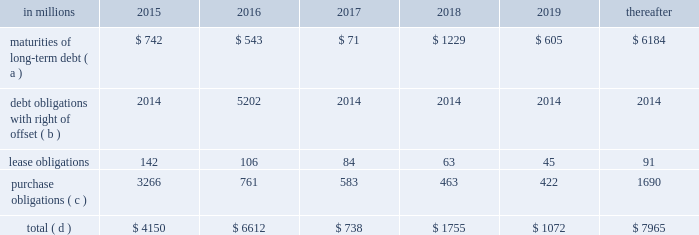On the credit rating of the company and a $ 200 million term loan with an interest rate of libor plus a margin of 175 basis points , both with maturity dates in 2017 .
The proceeds from these borrowings were used , along with available cash , to fund the acquisition of temple- inland .
During 2012 , international paper fully repaid the $ 1.2 billion term loan .
International paper utilizes interest rate swaps to change the mix of fixed and variable rate debt and manage interest expense .
At december 31 , 2012 , international paper had interest rate swaps with a total notional amount of $ 150 million and maturities in 2013 ( see note 14 derivatives and hedging activities on pages 70 through 74 of item 8 .
Financial statements and supplementary data ) .
During 2012 , existing swaps and the amortization of deferred gains on previously terminated swaps decreased the weighted average cost of debt from 6.8% ( 6.8 % ) to an effective rate of 6.6% ( 6.6 % ) .
The inclusion of the offsetting interest income from short- term investments reduced this effective rate to 6.2% ( 6.2 % ) .
Other financing activities during 2012 included the issuance of approximately 1.9 million shares of treasury stock , net of restricted stock withholding , and 1.0 million shares of common stock for various incentive plans , including stock options exercises that generated approximately $ 108 million of cash .
Payment of restricted stock withholding taxes totaled $ 35 million .
Off-balance sheet variable interest entities information concerning off-balance sheet variable interest entities is set forth in note 12 variable interest entities and preferred securities of subsidiaries on pages 67 through 69 of item 8 .
Financial statements and supplementary data for discussion .
Liquidity and capital resources outlook for 2015 capital expenditures and long-term debt international paper expects to be able to meet projected capital expenditures , service existing debt and meet working capital and dividend requirements during 2015 through current cash balances and cash from operations .
Additionally , the company has existing credit facilities totaling $ 2.0 billion of which nothing has been used .
The company was in compliance with all its debt covenants at december 31 , 2014 .
The company 2019s financial covenants require the maintenance of a minimum net worth of $ 9 billion and a total debt-to- capital ratio of less than 60% ( 60 % ) .
Net worth is defined as the sum of common stock , paid-in capital and retained earnings , less treasury stock plus any cumulative goodwill impairment charges .
The calculation also excludes accumulated other comprehensive income/ loss and nonrecourse financial liabilities of special purpose entities .
The total debt-to-capital ratio is defined as total debt divided by the sum of total debt plus net worth .
At december 31 , 2014 , international paper 2019s net worth was $ 14.0 billion , and the total-debt- to-capital ratio was 40% ( 40 % ) .
The company will continue to rely upon debt and capital markets for the majority of any necessary long-term funding not provided by operating cash flows .
Funding decisions will be guided by our capital structure planning objectives .
The primary goals of the company 2019s capital structure planning are to maximize financial flexibility and preserve liquidity while reducing interest expense .
The majority of international paper 2019s debt is accessed through global public capital markets where we have a wide base of investors .
Maintaining an investment grade credit rating is an important element of international paper 2019s financing strategy .
At december 31 , 2014 , the company held long-term credit ratings of bbb ( stable outlook ) and baa2 ( stable outlook ) by s&p and moody 2019s , respectively .
Contractual obligations for future payments under existing debt and lease commitments and purchase obligations at december 31 , 2014 , were as follows: .
( a ) total debt includes scheduled principal payments only .
( b ) represents debt obligations borrowed from non-consolidated variable interest entities for which international paper has , and intends to effect , a legal right to offset these obligations with investments held in the entities .
Accordingly , in its consolidated balance sheet at december 31 , 2014 , international paper has offset approximately $ 5.2 billion of interests in the entities against this $ 5.3 billion of debt obligations held by the entities ( see note 12 variable interest entities and preferred securities of subsidiaries on pages 67 through 69 in item 8 .
Financial statements and supplementary data ) .
( c ) includes $ 2.3 billion relating to fiber supply agreements entered into at the time of the 2006 transformation plan forestland sales and in conjunction with the 2008 acquisition of weyerhaeuser company 2019s containerboard , packaging and recycling business .
( d ) not included in the above table due to the uncertainty as to the amount and timing of the payment are unrecognized tax benefits of approximately $ 119 million .
As discussed in note 12 variable interest entities and preferred securities of subsidiaries on pages 67 through 69 in item 8 .
Financial statements and supplementary data , in connection with the 2006 international paper installment sale of forestlands , we received $ 4.8 billion of installment notes ( or timber notes ) , which we contributed to certain non- consolidated borrower entities .
The installment notes mature in august 2016 ( unless extended ) .
The deferred .
In 2016 what was the percent of the maturities of long-term debt to the total contractual obligations for future payments under existing debt and lease commitments? 
Computations: (543 / 6612)
Answer: 0.08212. 